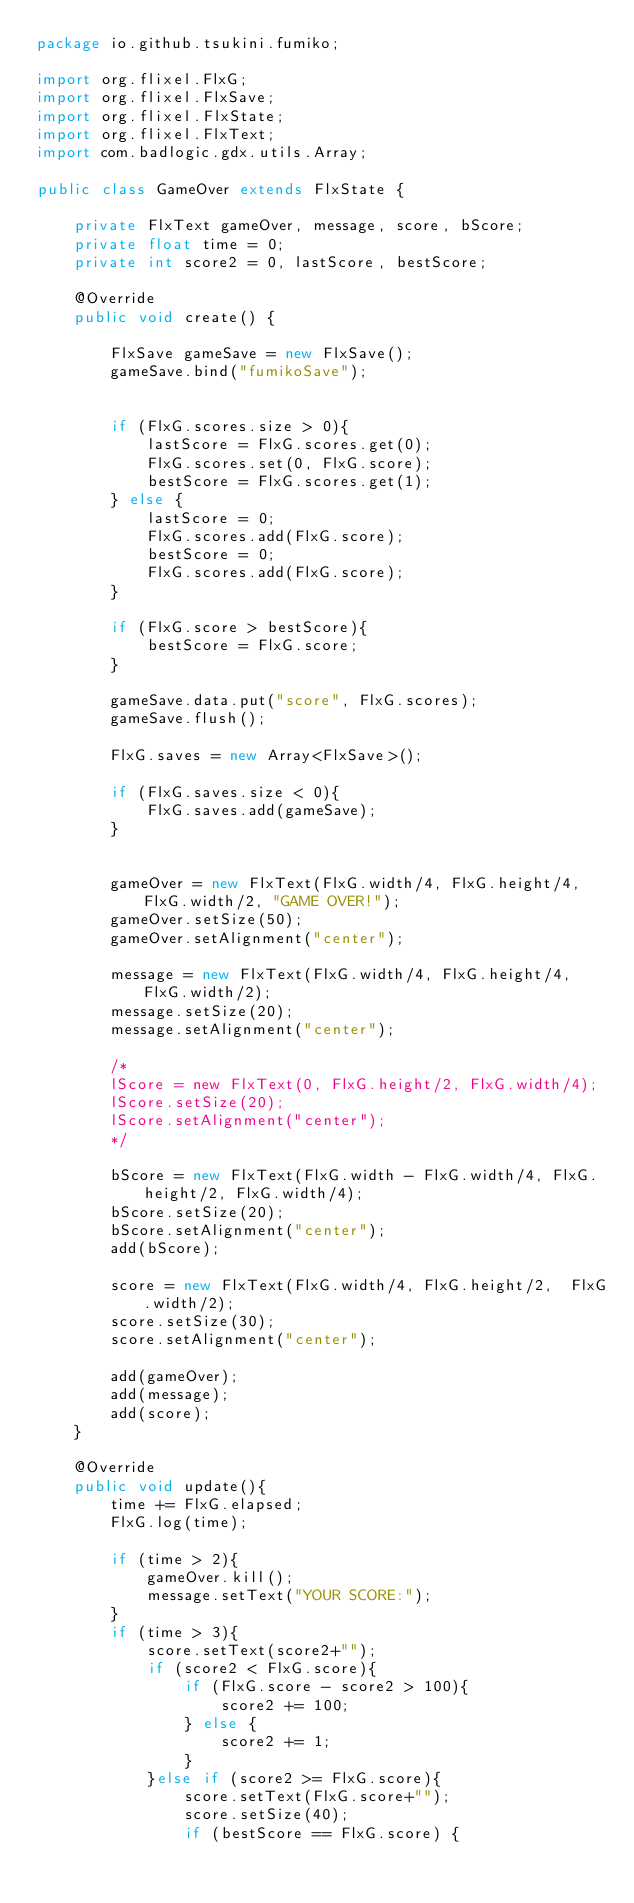Convert code to text. <code><loc_0><loc_0><loc_500><loc_500><_Java_>package io.github.tsukini.fumiko;

import org.flixel.FlxG;
import org.flixel.FlxSave;
import org.flixel.FlxState;
import org.flixel.FlxText;
import com.badlogic.gdx.utils.Array;

public class GameOver extends FlxState {

	private FlxText gameOver, message, score, bScore;
	private float time = 0;
	private int score2 = 0, lastScore, bestScore;
		
	@Override
	public void create() {

        FlxSave gameSave = new FlxSave();
        gameSave.bind("fumikoSave");


        if (FlxG.scores.size > 0){
            lastScore = FlxG.scores.get(0);
            FlxG.scores.set(0, FlxG.score);
            bestScore = FlxG.scores.get(1);
        } else {
            lastScore = 0;
            FlxG.scores.add(FlxG.score);
            bestScore = 0;
            FlxG.scores.add(FlxG.score);
        }

        if (FlxG.score > bestScore){
            bestScore = FlxG.score;
        }

        gameSave.data.put("score", FlxG.scores);
        gameSave.flush();

	    FlxG.saves = new Array<FlxSave>();

        if (FlxG.saves.size < 0){
			FlxG.saves.add(gameSave);
		}

		
		gameOver = new FlxText(FlxG.width/4, FlxG.height/4, FlxG.width/2, "GAME OVER!");
		gameOver.setSize(50);
		gameOver.setAlignment("center");
				
		message = new FlxText(FlxG.width/4, FlxG.height/4, FlxG.width/2);
		message.setSize(20);
		message.setAlignment("center");
		
		/*
		lScore = new FlxText(0, FlxG.height/2, FlxG.width/4);
		lScore.setSize(20);
		lScore.setAlignment("center");
		*/

		bScore = new FlxText(FlxG.width - FlxG.width/4, FlxG.height/2, FlxG.width/4);
		bScore.setSize(20);
		bScore.setAlignment("center");
		add(bScore);
		
		score = new FlxText(FlxG.width/4, FlxG.height/2,  FlxG.width/2);
		score.setSize(30);
		score.setAlignment("center");
		
		add(gameOver);
		add(message);
		add(score);
	}
	
	@Override
	public void update(){
		time += FlxG.elapsed;
		FlxG.log(time);
		
		if (time > 2){
			gameOver.kill();
			message.setText("YOUR SCORE:");
		}
		if (time > 3){
			score.setText(score2+"");
			if (score2 < FlxG.score){
                if (FlxG.score - score2 > 100){
                    score2 += 100;
                } else {
                    score2 += 1;
                }
			}else if (score2 >= FlxG.score){
				score.setText(FlxG.score+"");
				score.setSize(40);
                if (bestScore == FlxG.score) {</code> 